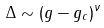<formula> <loc_0><loc_0><loc_500><loc_500>\Delta \sim ( g - g _ { c } ) ^ { \nu }</formula> 